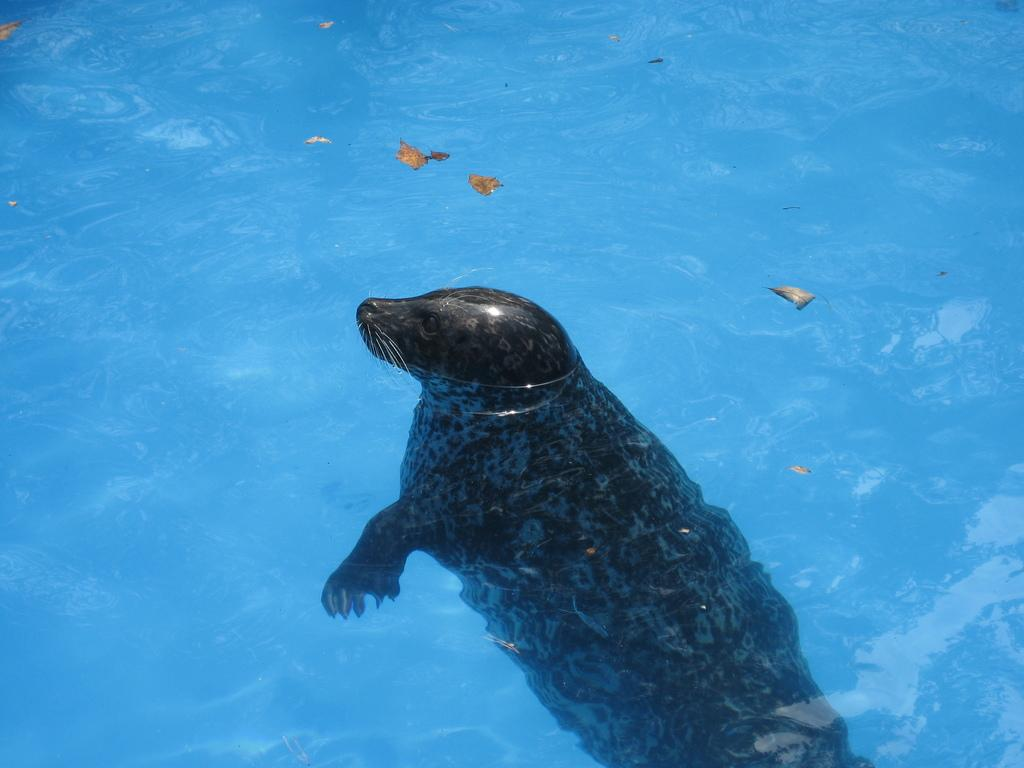What animal is present in the image? There is a seal in the image. Where is the seal located? The seal is in the water. What else can be seen floating in the water? There are dried leaves floating in the water. What is the tendency of the kettle in the image? There is no kettle present in the image, so it is not possible to determine its tendency. 